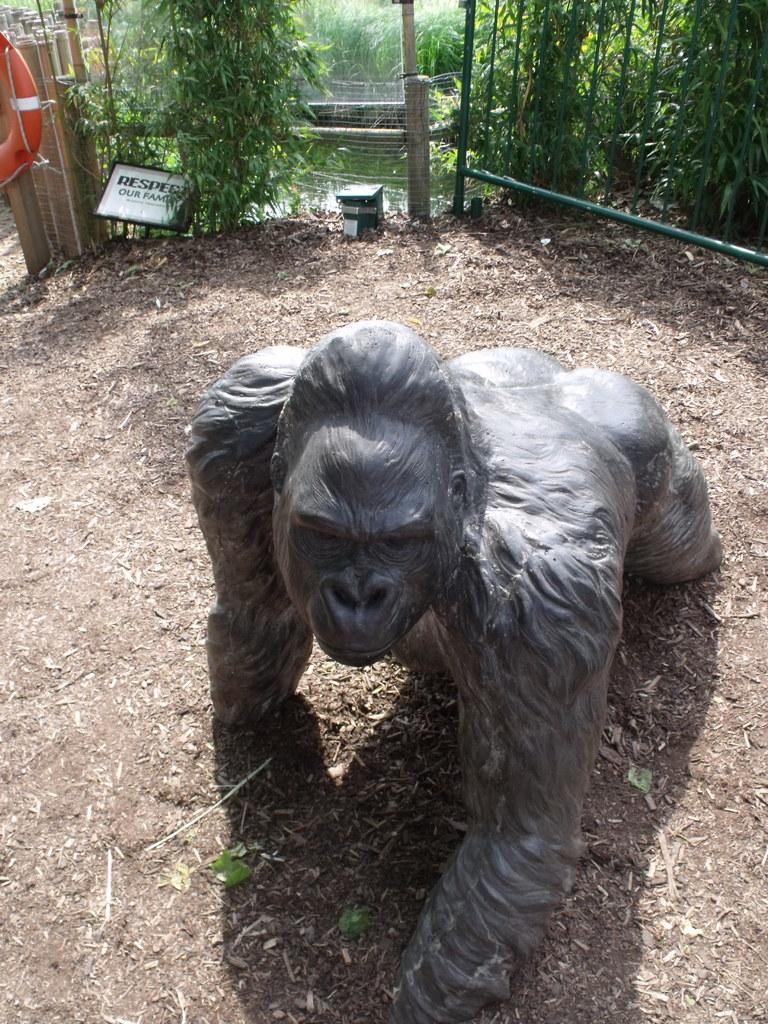What type of object is the main subject in the image? There is an animal statue in the image. What color is the animal statue? The statue is black in color. What can be seen in the background of the image? There is a white board and trees in the background of the image. What color are the trees? The trees are green in color. What else is visible in the image? There is water visible in the image. What type of badge is the animal statue wearing in the image? There is no badge present on the animal statue in the image. What is the purpose of the water in the image? The purpose of the water in the image cannot be determined from the image alone, as it may be decorative, functional, or simply part of the natural setting. 